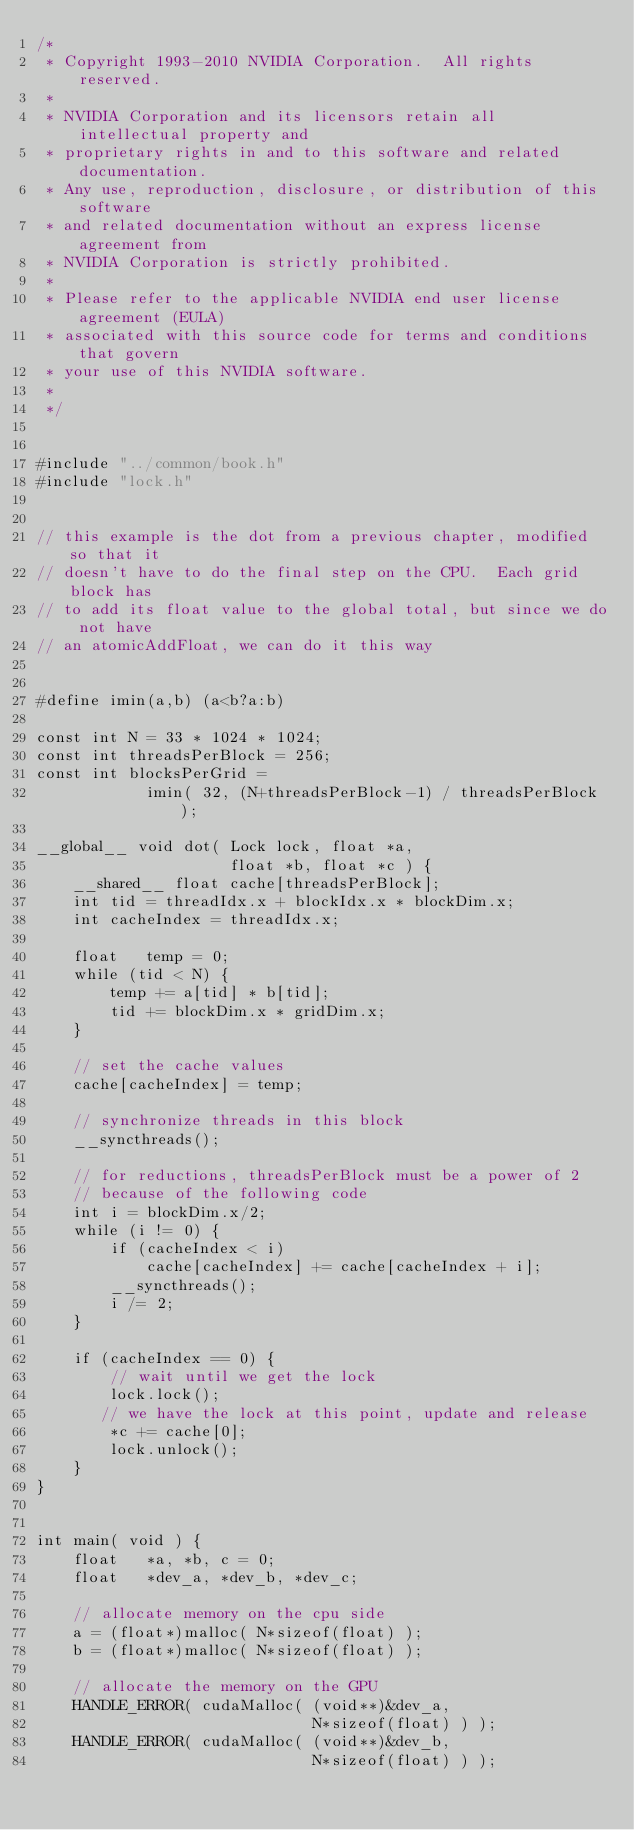Convert code to text. <code><loc_0><loc_0><loc_500><loc_500><_Cuda_>/*
 * Copyright 1993-2010 NVIDIA Corporation.  All rights reserved.
 *
 * NVIDIA Corporation and its licensors retain all intellectual property and 
 * proprietary rights in and to this software and related documentation. 
 * Any use, reproduction, disclosure, or distribution of this software 
 * and related documentation without an express license agreement from
 * NVIDIA Corporation is strictly prohibited.
 *
 * Please refer to the applicable NVIDIA end user license agreement (EULA) 
 * associated with this source code for terms and conditions that govern 
 * your use of this NVIDIA software.
 * 
 */


#include "../common/book.h"
#include "lock.h"


// this example is the dot from a previous chapter, modified so that it
// doesn't have to do the final step on the CPU.  Each grid block has
// to add its float value to the global total, but since we do not have
// an atomicAddFloat, we can do it this way


#define imin(a,b) (a<b?a:b)

const int N = 33 * 1024 * 1024;
const int threadsPerBlock = 256;
const int blocksPerGrid =
            imin( 32, (N+threadsPerBlock-1) / threadsPerBlock );

__global__ void dot( Lock lock, float *a,
                     float *b, float *c ) {
    __shared__ float cache[threadsPerBlock];
    int tid = threadIdx.x + blockIdx.x * blockDim.x;
    int cacheIndex = threadIdx.x;

    float   temp = 0;
    while (tid < N) {
        temp += a[tid] * b[tid];
        tid += blockDim.x * gridDim.x;
    }
    
    // set the cache values
    cache[cacheIndex] = temp;
    
    // synchronize threads in this block
    __syncthreads();

    // for reductions, threadsPerBlock must be a power of 2
    // because of the following code
    int i = blockDim.x/2;
    while (i != 0) {
        if (cacheIndex < i)
            cache[cacheIndex] += cache[cacheIndex + i];
        __syncthreads();
        i /= 2;
    }

    if (cacheIndex == 0) {
        // wait until we get the lock
        lock.lock();
       // we have the lock at this point, update and release
        *c += cache[0];
        lock.unlock();
    }
}


int main( void ) {
    float   *a, *b, c = 0;
    float   *dev_a, *dev_b, *dev_c;

    // allocate memory on the cpu side
    a = (float*)malloc( N*sizeof(float) );
    b = (float*)malloc( N*sizeof(float) );

    // allocate the memory on the GPU
    HANDLE_ERROR( cudaMalloc( (void**)&dev_a,
                              N*sizeof(float) ) );
    HANDLE_ERROR( cudaMalloc( (void**)&dev_b,
                              N*sizeof(float) ) );</code> 